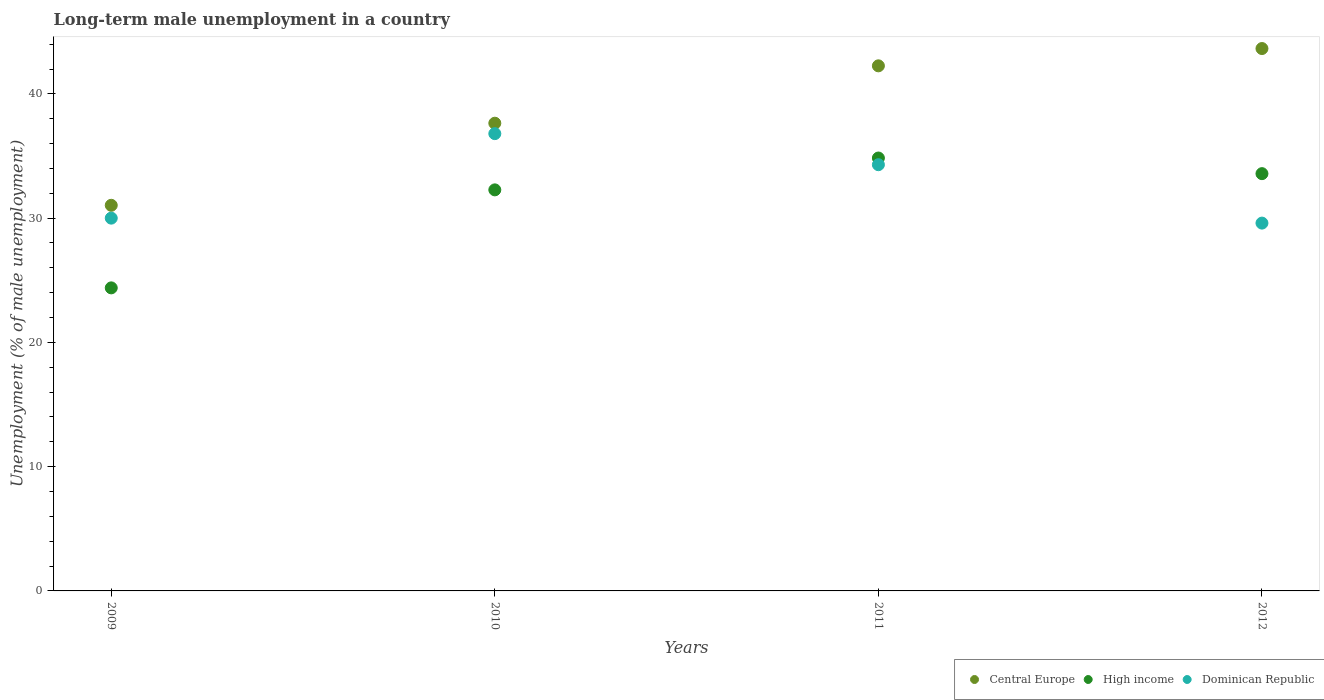What is the percentage of long-term unemployed male population in High income in 2011?
Give a very brief answer. 34.84. Across all years, what is the maximum percentage of long-term unemployed male population in High income?
Give a very brief answer. 34.84. Across all years, what is the minimum percentage of long-term unemployed male population in High income?
Provide a succinct answer. 24.39. In which year was the percentage of long-term unemployed male population in Dominican Republic maximum?
Your answer should be very brief. 2010. In which year was the percentage of long-term unemployed male population in High income minimum?
Your answer should be compact. 2009. What is the total percentage of long-term unemployed male population in Dominican Republic in the graph?
Ensure brevity in your answer.  130.7. What is the difference between the percentage of long-term unemployed male population in Dominican Republic in 2011 and that in 2012?
Give a very brief answer. 4.7. What is the difference between the percentage of long-term unemployed male population in High income in 2011 and the percentage of long-term unemployed male population in Central Europe in 2009?
Your answer should be very brief. 3.81. What is the average percentage of long-term unemployed male population in Central Europe per year?
Your answer should be very brief. 38.64. In the year 2012, what is the difference between the percentage of long-term unemployed male population in High income and percentage of long-term unemployed male population in Central Europe?
Keep it short and to the point. -10.07. What is the ratio of the percentage of long-term unemployed male population in Central Europe in 2009 to that in 2011?
Provide a succinct answer. 0.73. Is the difference between the percentage of long-term unemployed male population in High income in 2010 and 2011 greater than the difference between the percentage of long-term unemployed male population in Central Europe in 2010 and 2011?
Provide a short and direct response. Yes. What is the difference between the highest and the lowest percentage of long-term unemployed male population in High income?
Keep it short and to the point. 10.45. In how many years, is the percentage of long-term unemployed male population in Central Europe greater than the average percentage of long-term unemployed male population in Central Europe taken over all years?
Give a very brief answer. 2. Is the sum of the percentage of long-term unemployed male population in High income in 2009 and 2010 greater than the maximum percentage of long-term unemployed male population in Dominican Republic across all years?
Your answer should be compact. Yes. Is the percentage of long-term unemployed male population in Central Europe strictly greater than the percentage of long-term unemployed male population in Dominican Republic over the years?
Keep it short and to the point. Yes. Is the percentage of long-term unemployed male population in Central Europe strictly less than the percentage of long-term unemployed male population in High income over the years?
Provide a short and direct response. No. How many dotlines are there?
Your answer should be compact. 3. How many years are there in the graph?
Give a very brief answer. 4. Does the graph contain any zero values?
Offer a terse response. No. Does the graph contain grids?
Ensure brevity in your answer.  No. Where does the legend appear in the graph?
Make the answer very short. Bottom right. How are the legend labels stacked?
Offer a very short reply. Horizontal. What is the title of the graph?
Give a very brief answer. Long-term male unemployment in a country. Does "Namibia" appear as one of the legend labels in the graph?
Make the answer very short. No. What is the label or title of the X-axis?
Your answer should be compact. Years. What is the label or title of the Y-axis?
Offer a terse response. Unemployment (% of male unemployment). What is the Unemployment (% of male unemployment) of Central Europe in 2009?
Provide a short and direct response. 31.03. What is the Unemployment (% of male unemployment) of High income in 2009?
Make the answer very short. 24.39. What is the Unemployment (% of male unemployment) in Dominican Republic in 2009?
Your answer should be very brief. 30. What is the Unemployment (% of male unemployment) of Central Europe in 2010?
Provide a short and direct response. 37.64. What is the Unemployment (% of male unemployment) in High income in 2010?
Give a very brief answer. 32.28. What is the Unemployment (% of male unemployment) in Dominican Republic in 2010?
Your answer should be compact. 36.8. What is the Unemployment (% of male unemployment) of Central Europe in 2011?
Your answer should be very brief. 42.26. What is the Unemployment (% of male unemployment) of High income in 2011?
Make the answer very short. 34.84. What is the Unemployment (% of male unemployment) in Dominican Republic in 2011?
Offer a terse response. 34.3. What is the Unemployment (% of male unemployment) in Central Europe in 2012?
Your response must be concise. 43.65. What is the Unemployment (% of male unemployment) in High income in 2012?
Ensure brevity in your answer.  33.58. What is the Unemployment (% of male unemployment) of Dominican Republic in 2012?
Offer a terse response. 29.6. Across all years, what is the maximum Unemployment (% of male unemployment) of Central Europe?
Provide a short and direct response. 43.65. Across all years, what is the maximum Unemployment (% of male unemployment) of High income?
Your response must be concise. 34.84. Across all years, what is the maximum Unemployment (% of male unemployment) in Dominican Republic?
Make the answer very short. 36.8. Across all years, what is the minimum Unemployment (% of male unemployment) of Central Europe?
Offer a terse response. 31.03. Across all years, what is the minimum Unemployment (% of male unemployment) in High income?
Give a very brief answer. 24.39. Across all years, what is the minimum Unemployment (% of male unemployment) of Dominican Republic?
Offer a very short reply. 29.6. What is the total Unemployment (% of male unemployment) of Central Europe in the graph?
Give a very brief answer. 154.58. What is the total Unemployment (% of male unemployment) in High income in the graph?
Offer a terse response. 125.08. What is the total Unemployment (% of male unemployment) in Dominican Republic in the graph?
Give a very brief answer. 130.7. What is the difference between the Unemployment (% of male unemployment) in Central Europe in 2009 and that in 2010?
Provide a succinct answer. -6.61. What is the difference between the Unemployment (% of male unemployment) in High income in 2009 and that in 2010?
Offer a terse response. -7.89. What is the difference between the Unemployment (% of male unemployment) of Dominican Republic in 2009 and that in 2010?
Provide a succinct answer. -6.8. What is the difference between the Unemployment (% of male unemployment) of Central Europe in 2009 and that in 2011?
Offer a terse response. -11.22. What is the difference between the Unemployment (% of male unemployment) of High income in 2009 and that in 2011?
Your response must be concise. -10.45. What is the difference between the Unemployment (% of male unemployment) of Dominican Republic in 2009 and that in 2011?
Your answer should be very brief. -4.3. What is the difference between the Unemployment (% of male unemployment) in Central Europe in 2009 and that in 2012?
Offer a very short reply. -12.62. What is the difference between the Unemployment (% of male unemployment) in High income in 2009 and that in 2012?
Provide a short and direct response. -9.19. What is the difference between the Unemployment (% of male unemployment) in Central Europe in 2010 and that in 2011?
Provide a succinct answer. -4.62. What is the difference between the Unemployment (% of male unemployment) in High income in 2010 and that in 2011?
Provide a succinct answer. -2.56. What is the difference between the Unemployment (% of male unemployment) of Dominican Republic in 2010 and that in 2011?
Your answer should be very brief. 2.5. What is the difference between the Unemployment (% of male unemployment) in Central Europe in 2010 and that in 2012?
Offer a very short reply. -6.01. What is the difference between the Unemployment (% of male unemployment) of High income in 2010 and that in 2012?
Offer a terse response. -1.3. What is the difference between the Unemployment (% of male unemployment) of Dominican Republic in 2010 and that in 2012?
Offer a terse response. 7.2. What is the difference between the Unemployment (% of male unemployment) of Central Europe in 2011 and that in 2012?
Make the answer very short. -1.39. What is the difference between the Unemployment (% of male unemployment) of High income in 2011 and that in 2012?
Provide a short and direct response. 1.26. What is the difference between the Unemployment (% of male unemployment) in Central Europe in 2009 and the Unemployment (% of male unemployment) in High income in 2010?
Offer a terse response. -1.24. What is the difference between the Unemployment (% of male unemployment) in Central Europe in 2009 and the Unemployment (% of male unemployment) in Dominican Republic in 2010?
Ensure brevity in your answer.  -5.77. What is the difference between the Unemployment (% of male unemployment) of High income in 2009 and the Unemployment (% of male unemployment) of Dominican Republic in 2010?
Your answer should be compact. -12.41. What is the difference between the Unemployment (% of male unemployment) of Central Europe in 2009 and the Unemployment (% of male unemployment) of High income in 2011?
Provide a short and direct response. -3.81. What is the difference between the Unemployment (% of male unemployment) of Central Europe in 2009 and the Unemployment (% of male unemployment) of Dominican Republic in 2011?
Provide a succinct answer. -3.27. What is the difference between the Unemployment (% of male unemployment) of High income in 2009 and the Unemployment (% of male unemployment) of Dominican Republic in 2011?
Your response must be concise. -9.91. What is the difference between the Unemployment (% of male unemployment) of Central Europe in 2009 and the Unemployment (% of male unemployment) of High income in 2012?
Ensure brevity in your answer.  -2.55. What is the difference between the Unemployment (% of male unemployment) in Central Europe in 2009 and the Unemployment (% of male unemployment) in Dominican Republic in 2012?
Ensure brevity in your answer.  1.43. What is the difference between the Unemployment (% of male unemployment) of High income in 2009 and the Unemployment (% of male unemployment) of Dominican Republic in 2012?
Keep it short and to the point. -5.21. What is the difference between the Unemployment (% of male unemployment) of Central Europe in 2010 and the Unemployment (% of male unemployment) of High income in 2011?
Make the answer very short. 2.8. What is the difference between the Unemployment (% of male unemployment) in Central Europe in 2010 and the Unemployment (% of male unemployment) in Dominican Republic in 2011?
Provide a succinct answer. 3.34. What is the difference between the Unemployment (% of male unemployment) in High income in 2010 and the Unemployment (% of male unemployment) in Dominican Republic in 2011?
Provide a succinct answer. -2.02. What is the difference between the Unemployment (% of male unemployment) of Central Europe in 2010 and the Unemployment (% of male unemployment) of High income in 2012?
Provide a short and direct response. 4.06. What is the difference between the Unemployment (% of male unemployment) in Central Europe in 2010 and the Unemployment (% of male unemployment) in Dominican Republic in 2012?
Your response must be concise. 8.04. What is the difference between the Unemployment (% of male unemployment) in High income in 2010 and the Unemployment (% of male unemployment) in Dominican Republic in 2012?
Give a very brief answer. 2.68. What is the difference between the Unemployment (% of male unemployment) in Central Europe in 2011 and the Unemployment (% of male unemployment) in High income in 2012?
Your answer should be very brief. 8.68. What is the difference between the Unemployment (% of male unemployment) in Central Europe in 2011 and the Unemployment (% of male unemployment) in Dominican Republic in 2012?
Offer a very short reply. 12.66. What is the difference between the Unemployment (% of male unemployment) of High income in 2011 and the Unemployment (% of male unemployment) of Dominican Republic in 2012?
Your answer should be compact. 5.24. What is the average Unemployment (% of male unemployment) in Central Europe per year?
Provide a short and direct response. 38.64. What is the average Unemployment (% of male unemployment) of High income per year?
Make the answer very short. 31.27. What is the average Unemployment (% of male unemployment) of Dominican Republic per year?
Your answer should be very brief. 32.67. In the year 2009, what is the difference between the Unemployment (% of male unemployment) of Central Europe and Unemployment (% of male unemployment) of High income?
Your answer should be very brief. 6.64. In the year 2009, what is the difference between the Unemployment (% of male unemployment) of Central Europe and Unemployment (% of male unemployment) of Dominican Republic?
Provide a succinct answer. 1.03. In the year 2009, what is the difference between the Unemployment (% of male unemployment) in High income and Unemployment (% of male unemployment) in Dominican Republic?
Your answer should be compact. -5.61. In the year 2010, what is the difference between the Unemployment (% of male unemployment) of Central Europe and Unemployment (% of male unemployment) of High income?
Give a very brief answer. 5.36. In the year 2010, what is the difference between the Unemployment (% of male unemployment) of Central Europe and Unemployment (% of male unemployment) of Dominican Republic?
Your answer should be very brief. 0.84. In the year 2010, what is the difference between the Unemployment (% of male unemployment) in High income and Unemployment (% of male unemployment) in Dominican Republic?
Make the answer very short. -4.52. In the year 2011, what is the difference between the Unemployment (% of male unemployment) in Central Europe and Unemployment (% of male unemployment) in High income?
Your response must be concise. 7.42. In the year 2011, what is the difference between the Unemployment (% of male unemployment) in Central Europe and Unemployment (% of male unemployment) in Dominican Republic?
Provide a short and direct response. 7.96. In the year 2011, what is the difference between the Unemployment (% of male unemployment) of High income and Unemployment (% of male unemployment) of Dominican Republic?
Your answer should be compact. 0.54. In the year 2012, what is the difference between the Unemployment (% of male unemployment) of Central Europe and Unemployment (% of male unemployment) of High income?
Your answer should be very brief. 10.07. In the year 2012, what is the difference between the Unemployment (% of male unemployment) in Central Europe and Unemployment (% of male unemployment) in Dominican Republic?
Give a very brief answer. 14.05. In the year 2012, what is the difference between the Unemployment (% of male unemployment) of High income and Unemployment (% of male unemployment) of Dominican Republic?
Provide a short and direct response. 3.98. What is the ratio of the Unemployment (% of male unemployment) in Central Europe in 2009 to that in 2010?
Offer a very short reply. 0.82. What is the ratio of the Unemployment (% of male unemployment) in High income in 2009 to that in 2010?
Give a very brief answer. 0.76. What is the ratio of the Unemployment (% of male unemployment) in Dominican Republic in 2009 to that in 2010?
Keep it short and to the point. 0.82. What is the ratio of the Unemployment (% of male unemployment) in Central Europe in 2009 to that in 2011?
Keep it short and to the point. 0.73. What is the ratio of the Unemployment (% of male unemployment) in High income in 2009 to that in 2011?
Your answer should be compact. 0.7. What is the ratio of the Unemployment (% of male unemployment) in Dominican Republic in 2009 to that in 2011?
Ensure brevity in your answer.  0.87. What is the ratio of the Unemployment (% of male unemployment) in Central Europe in 2009 to that in 2012?
Your answer should be very brief. 0.71. What is the ratio of the Unemployment (% of male unemployment) of High income in 2009 to that in 2012?
Provide a short and direct response. 0.73. What is the ratio of the Unemployment (% of male unemployment) of Dominican Republic in 2009 to that in 2012?
Keep it short and to the point. 1.01. What is the ratio of the Unemployment (% of male unemployment) of Central Europe in 2010 to that in 2011?
Keep it short and to the point. 0.89. What is the ratio of the Unemployment (% of male unemployment) of High income in 2010 to that in 2011?
Give a very brief answer. 0.93. What is the ratio of the Unemployment (% of male unemployment) in Dominican Republic in 2010 to that in 2011?
Offer a very short reply. 1.07. What is the ratio of the Unemployment (% of male unemployment) in Central Europe in 2010 to that in 2012?
Keep it short and to the point. 0.86. What is the ratio of the Unemployment (% of male unemployment) in High income in 2010 to that in 2012?
Ensure brevity in your answer.  0.96. What is the ratio of the Unemployment (% of male unemployment) in Dominican Republic in 2010 to that in 2012?
Provide a short and direct response. 1.24. What is the ratio of the Unemployment (% of male unemployment) of Central Europe in 2011 to that in 2012?
Give a very brief answer. 0.97. What is the ratio of the Unemployment (% of male unemployment) of High income in 2011 to that in 2012?
Offer a very short reply. 1.04. What is the ratio of the Unemployment (% of male unemployment) of Dominican Republic in 2011 to that in 2012?
Your answer should be very brief. 1.16. What is the difference between the highest and the second highest Unemployment (% of male unemployment) of Central Europe?
Offer a terse response. 1.39. What is the difference between the highest and the second highest Unemployment (% of male unemployment) of High income?
Keep it short and to the point. 1.26. What is the difference between the highest and the lowest Unemployment (% of male unemployment) of Central Europe?
Your response must be concise. 12.62. What is the difference between the highest and the lowest Unemployment (% of male unemployment) of High income?
Provide a short and direct response. 10.45. What is the difference between the highest and the lowest Unemployment (% of male unemployment) of Dominican Republic?
Keep it short and to the point. 7.2. 